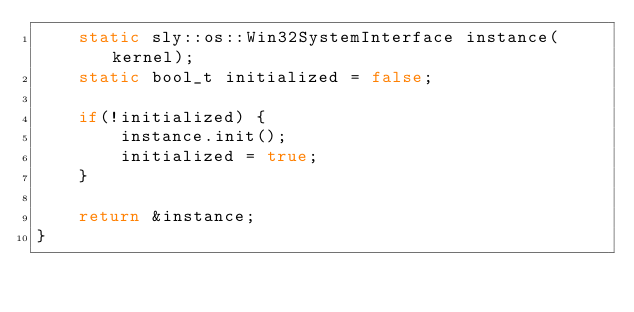<code> <loc_0><loc_0><loc_500><loc_500><_C++_>    static sly::os::Win32SystemInterface instance(kernel);
    static bool_t initialized = false;
    
    if(!initialized) {
        instance.init();
        initialized = true;
    }

    return &instance;
}</code> 